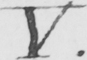What is written in this line of handwriting? V . 